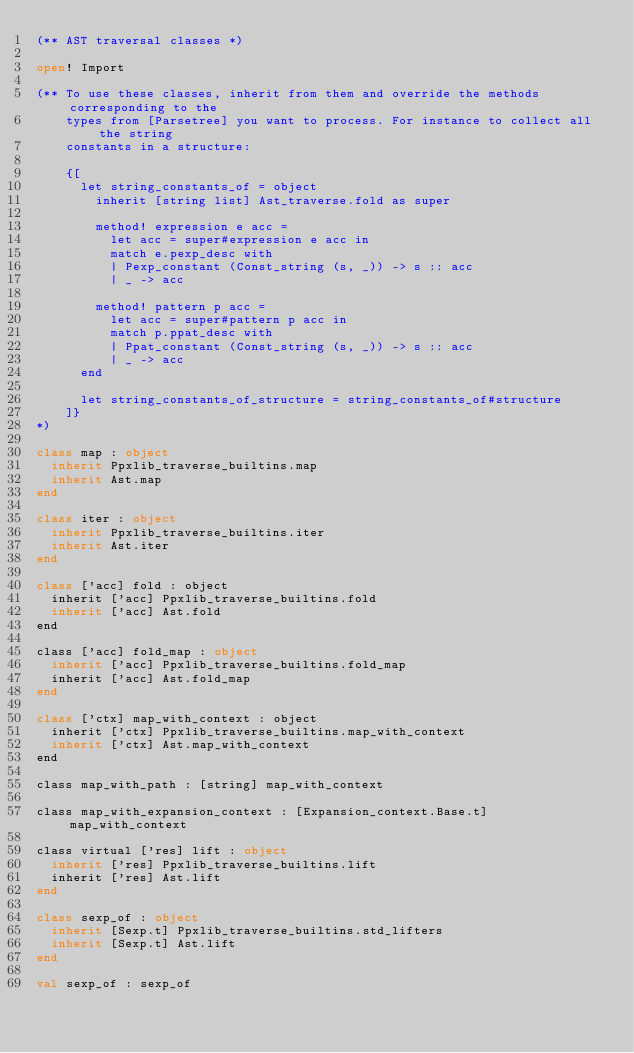Convert code to text. <code><loc_0><loc_0><loc_500><loc_500><_OCaml_>(** AST traversal classes *)

open! Import

(** To use these classes, inherit from them and override the methods corresponding to the
    types from [Parsetree] you want to process. For instance to collect all the string
    constants in a structure:

    {[
      let string_constants_of = object
        inherit [string list] Ast_traverse.fold as super

        method! expression e acc =
          let acc = super#expression e acc in
          match e.pexp_desc with
          | Pexp_constant (Const_string (s, _)) -> s :: acc
          | _ -> acc

        method! pattern p acc =
          let acc = super#pattern p acc in
          match p.ppat_desc with
          | Ppat_constant (Const_string (s, _)) -> s :: acc
          | _ -> acc
      end

      let string_constants_of_structure = string_constants_of#structure
    ]}
*)

class map : object
  inherit Ppxlib_traverse_builtins.map
  inherit Ast.map
end

class iter : object
  inherit Ppxlib_traverse_builtins.iter
  inherit Ast.iter
end

class ['acc] fold : object
  inherit ['acc] Ppxlib_traverse_builtins.fold
  inherit ['acc] Ast.fold
end

class ['acc] fold_map : object
  inherit ['acc] Ppxlib_traverse_builtins.fold_map
  inherit ['acc] Ast.fold_map
end

class ['ctx] map_with_context : object
  inherit ['ctx] Ppxlib_traverse_builtins.map_with_context
  inherit ['ctx] Ast.map_with_context
end

class map_with_path : [string] map_with_context

class map_with_expansion_context : [Expansion_context.Base.t] map_with_context

class virtual ['res] lift : object
  inherit ['res] Ppxlib_traverse_builtins.lift
  inherit ['res] Ast.lift
end

class sexp_of : object
  inherit [Sexp.t] Ppxlib_traverse_builtins.std_lifters
  inherit [Sexp.t] Ast.lift
end

val sexp_of : sexp_of
</code> 